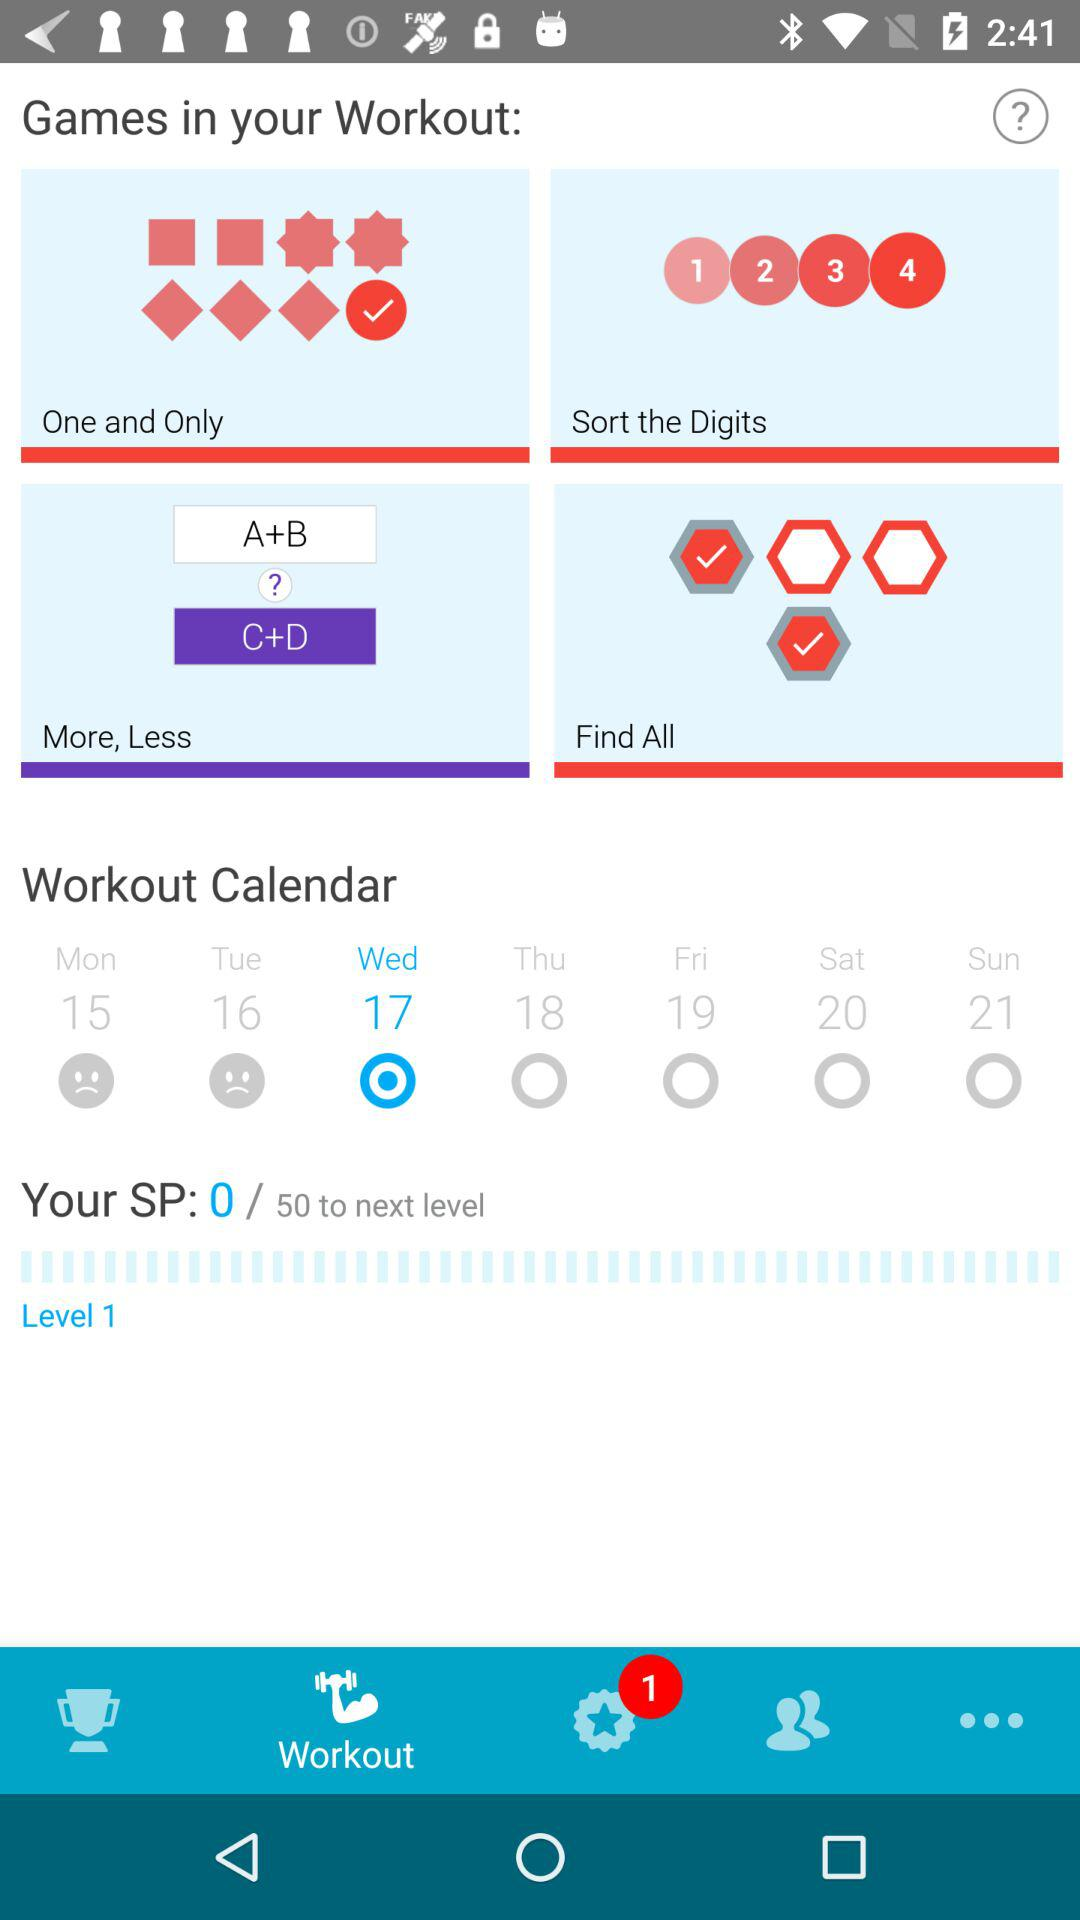What is the date for the workout? The date for the workout is Wednesday 17. 